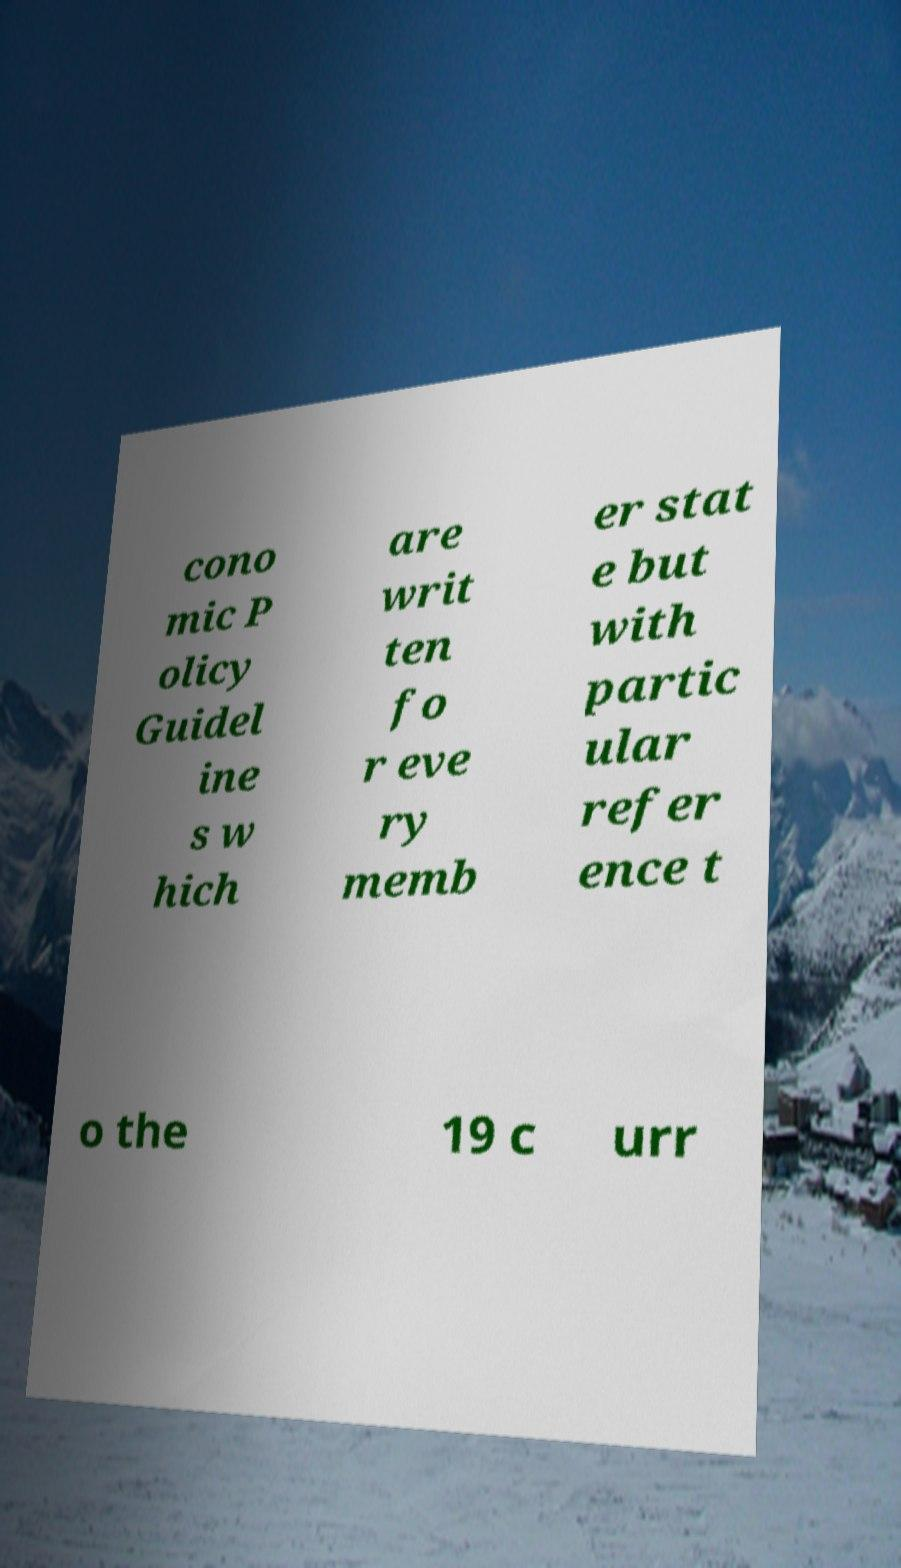Please identify and transcribe the text found in this image. cono mic P olicy Guidel ine s w hich are writ ten fo r eve ry memb er stat e but with partic ular refer ence t o the 19 c urr 